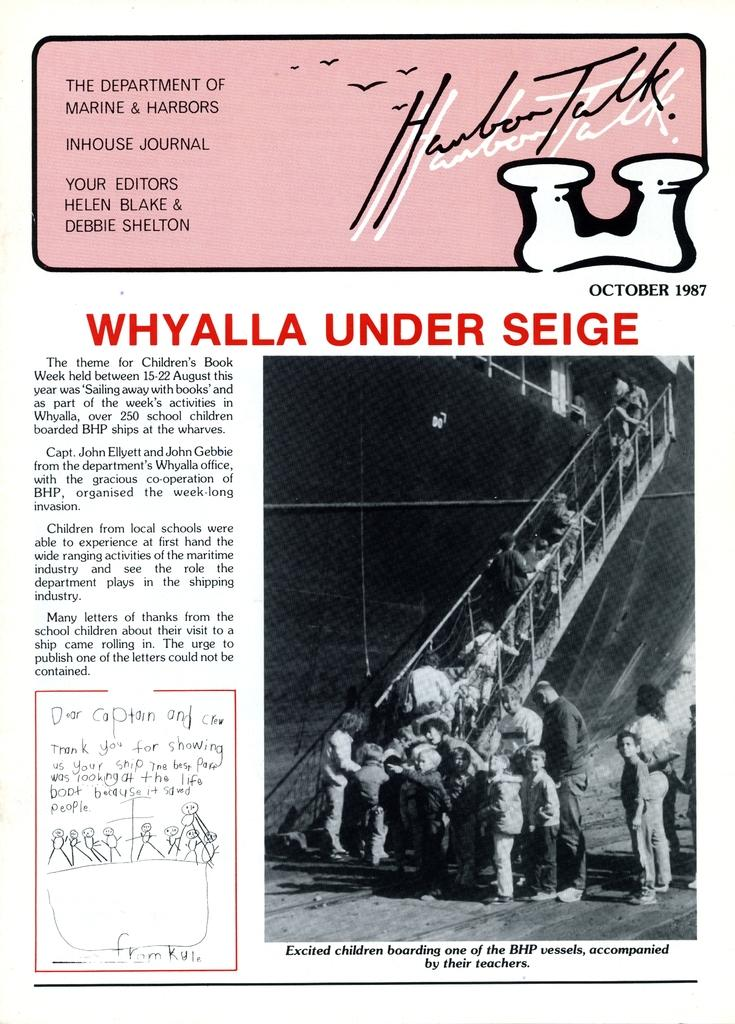<image>
Render a clear and concise summary of the photo. an article titled Whyalla under seige with picture 